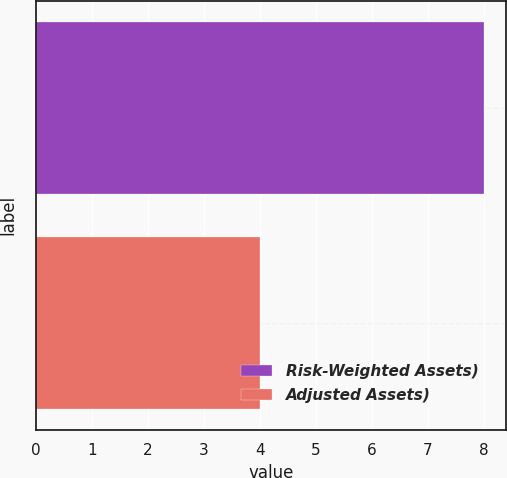<chart> <loc_0><loc_0><loc_500><loc_500><bar_chart><fcel>Risk-Weighted Assets)<fcel>Adjusted Assets)<nl><fcel>8<fcel>4<nl></chart> 